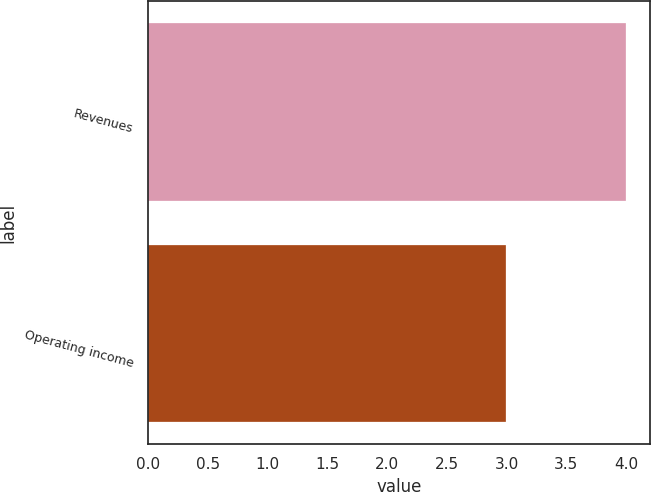Convert chart to OTSL. <chart><loc_0><loc_0><loc_500><loc_500><bar_chart><fcel>Revenues<fcel>Operating income<nl><fcel>4<fcel>3<nl></chart> 